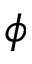<formula> <loc_0><loc_0><loc_500><loc_500>\phi</formula> 